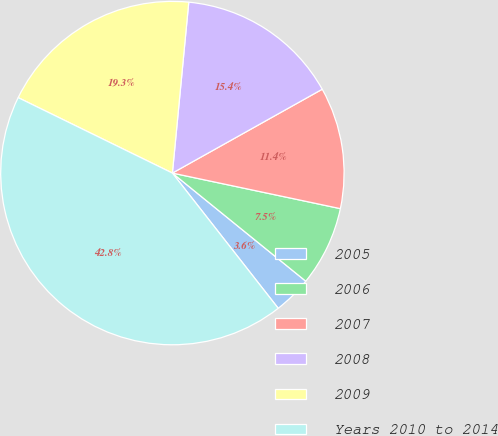Convert chart. <chart><loc_0><loc_0><loc_500><loc_500><pie_chart><fcel>2005<fcel>2006<fcel>2007<fcel>2008<fcel>2009<fcel>Years 2010 to 2014<nl><fcel>3.59%<fcel>7.52%<fcel>11.44%<fcel>15.36%<fcel>19.28%<fcel>42.81%<nl></chart> 